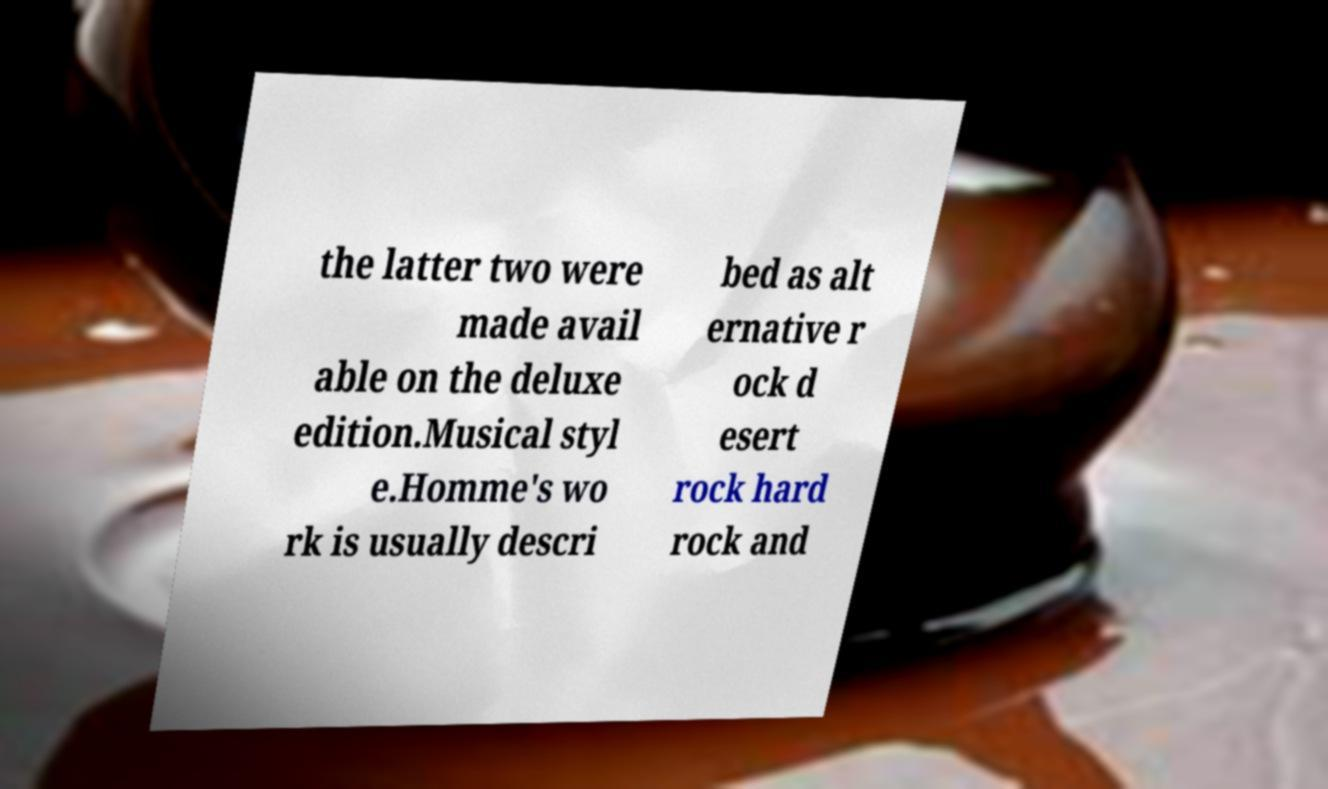There's text embedded in this image that I need extracted. Can you transcribe it verbatim? the latter two were made avail able on the deluxe edition.Musical styl e.Homme's wo rk is usually descri bed as alt ernative r ock d esert rock hard rock and 